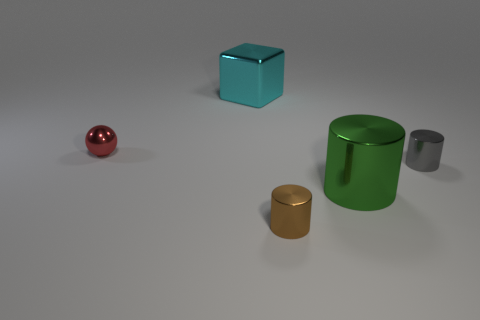There is a small metal object behind the gray metal cylinder; is it the same shape as the big cyan thing?
Your response must be concise. No. What number of green rubber things are there?
Give a very brief answer. 0. How many other metallic things have the same size as the brown metal object?
Offer a very short reply. 2. What material is the brown cylinder?
Ensure brevity in your answer.  Metal. Is there any other thing that is the same size as the cyan thing?
Provide a succinct answer. Yes. What size is the metallic thing that is left of the brown metal cylinder and to the right of the sphere?
Your response must be concise. Large. The big thing that is the same material as the large cyan cube is what shape?
Your response must be concise. Cylinder. Are the small red ball and the large object that is in front of the cyan block made of the same material?
Make the answer very short. Yes. Are there any tiny brown shiny things on the left side of the brown shiny cylinder to the left of the small gray shiny cylinder?
Keep it short and to the point. No. There is a brown object that is the same shape as the big green object; what material is it?
Offer a terse response. Metal. 